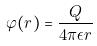<formula> <loc_0><loc_0><loc_500><loc_500>\varphi ( r ) = \frac { Q } { 4 \pi \epsilon r }</formula> 